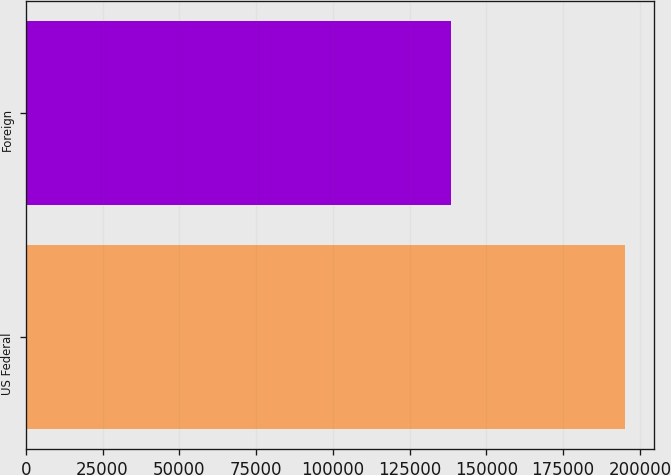<chart> <loc_0><loc_0><loc_500><loc_500><bar_chart><fcel>US Federal<fcel>Foreign<nl><fcel>194993<fcel>138543<nl></chart> 